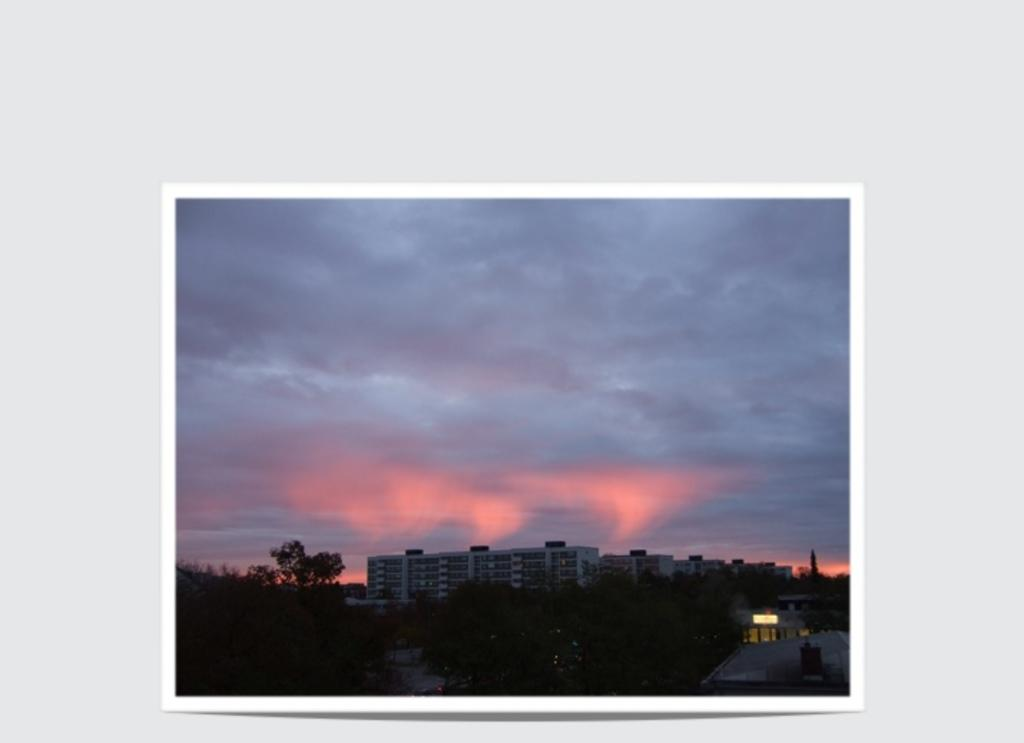What is the main subject of the image? The main subject of the image is a picture. What can be seen in the picture? The picture contains trees and buildings. What is visible at the top of the picture? The sky is visible at the top of the picture. What type of meat can be seen hanging from the trees in the picture? There is no meat visible in the picture; it only contains trees and buildings. What kind of button is attached to the buildings in the picture? There are no buttons present on the buildings in the picture. 